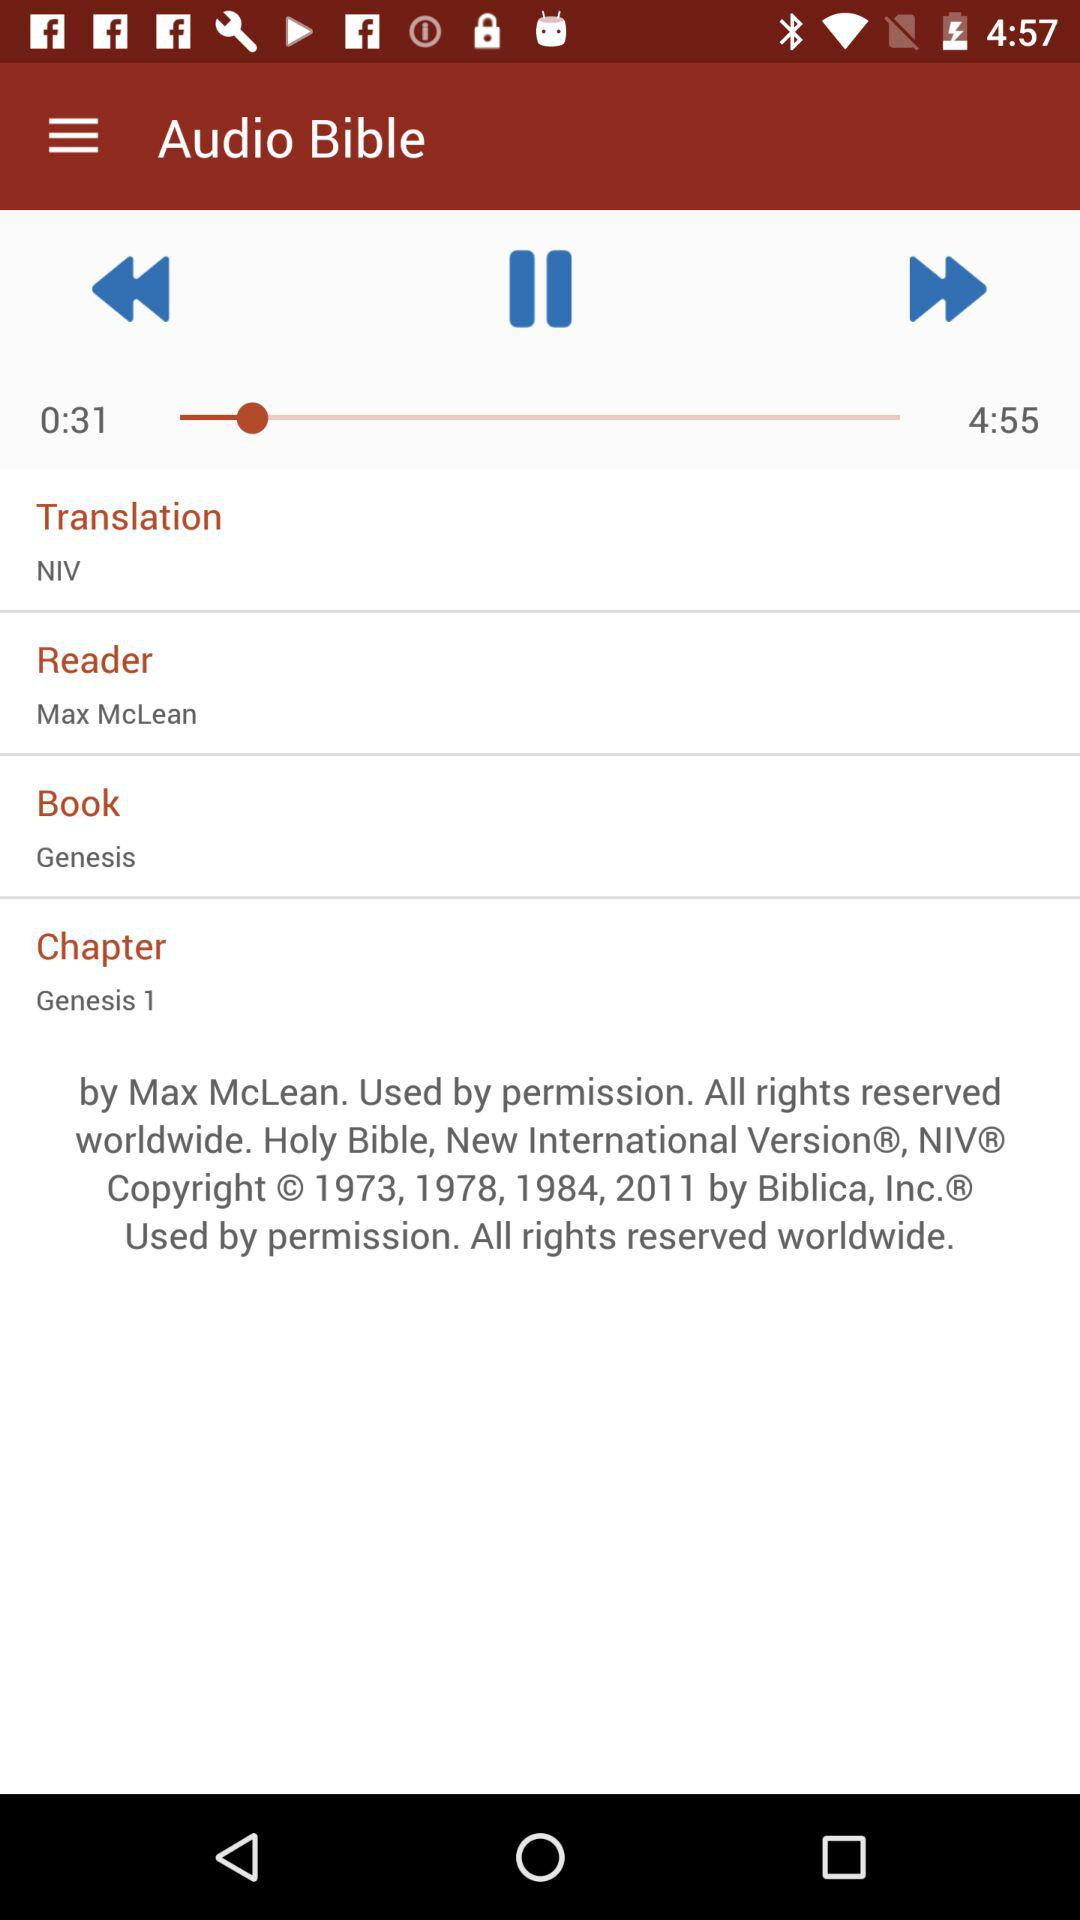What is the name of the book? The name of the book is "Genesis". 